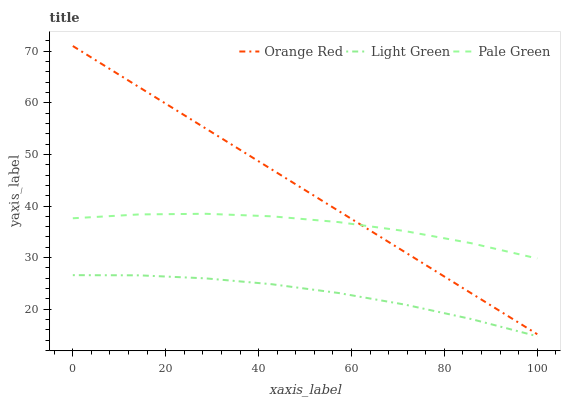Does Orange Red have the minimum area under the curve?
Answer yes or no. No. Does Light Green have the maximum area under the curve?
Answer yes or no. No. Is Light Green the smoothest?
Answer yes or no. No. Is Light Green the roughest?
Answer yes or no. No. Does Orange Red have the lowest value?
Answer yes or no. No. Does Light Green have the highest value?
Answer yes or no. No. Is Light Green less than Pale Green?
Answer yes or no. Yes. Is Pale Green greater than Light Green?
Answer yes or no. Yes. Does Light Green intersect Pale Green?
Answer yes or no. No. 